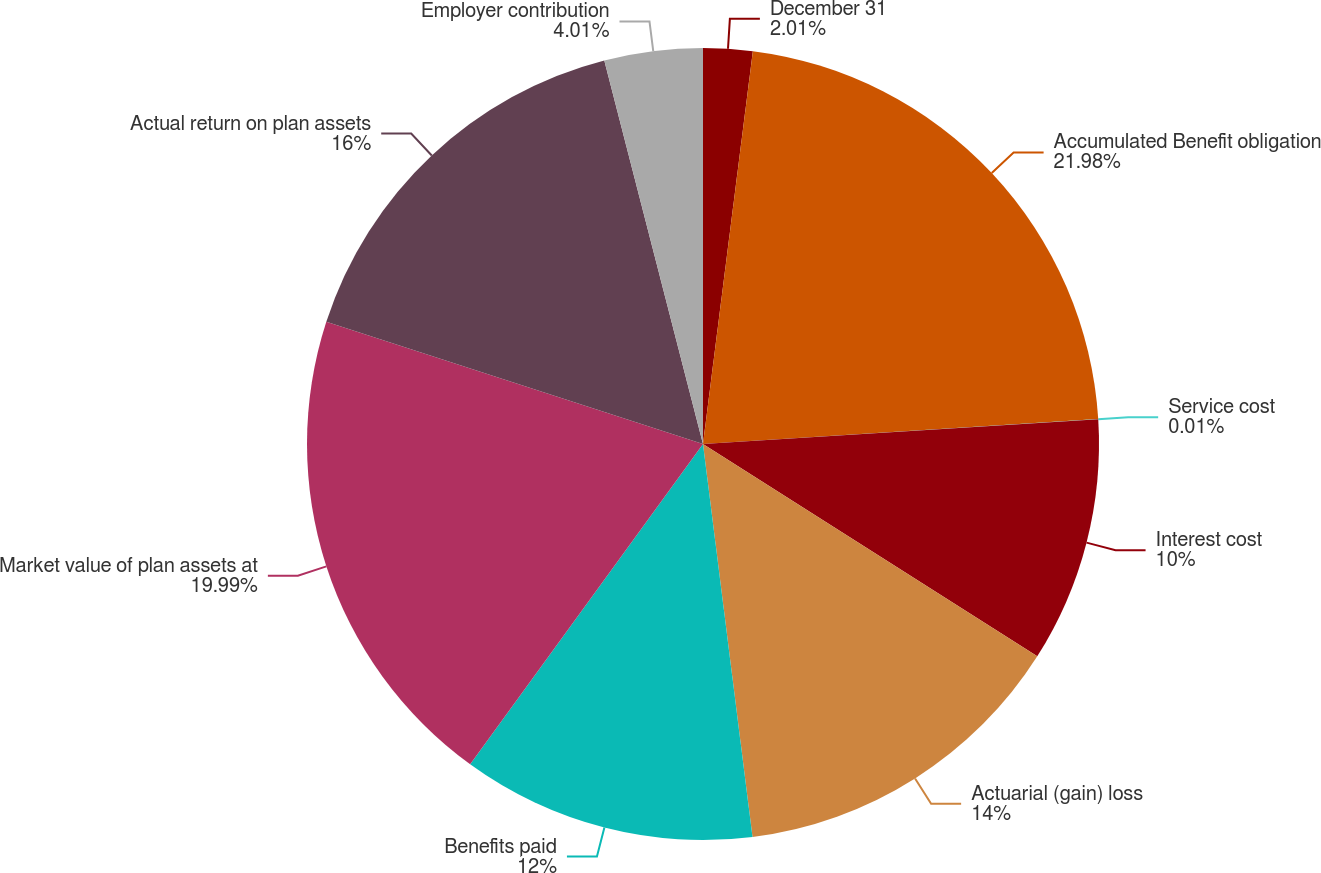<chart> <loc_0><loc_0><loc_500><loc_500><pie_chart><fcel>December 31<fcel>Accumulated Benefit obligation<fcel>Service cost<fcel>Interest cost<fcel>Actuarial (gain) loss<fcel>Benefits paid<fcel>Market value of plan assets at<fcel>Actual return on plan assets<fcel>Employer contribution<nl><fcel>2.01%<fcel>21.99%<fcel>0.01%<fcel>10.0%<fcel>14.0%<fcel>12.0%<fcel>19.99%<fcel>16.0%<fcel>4.01%<nl></chart> 